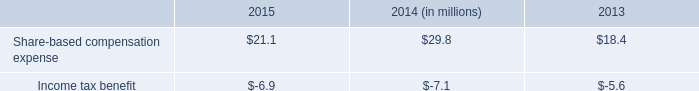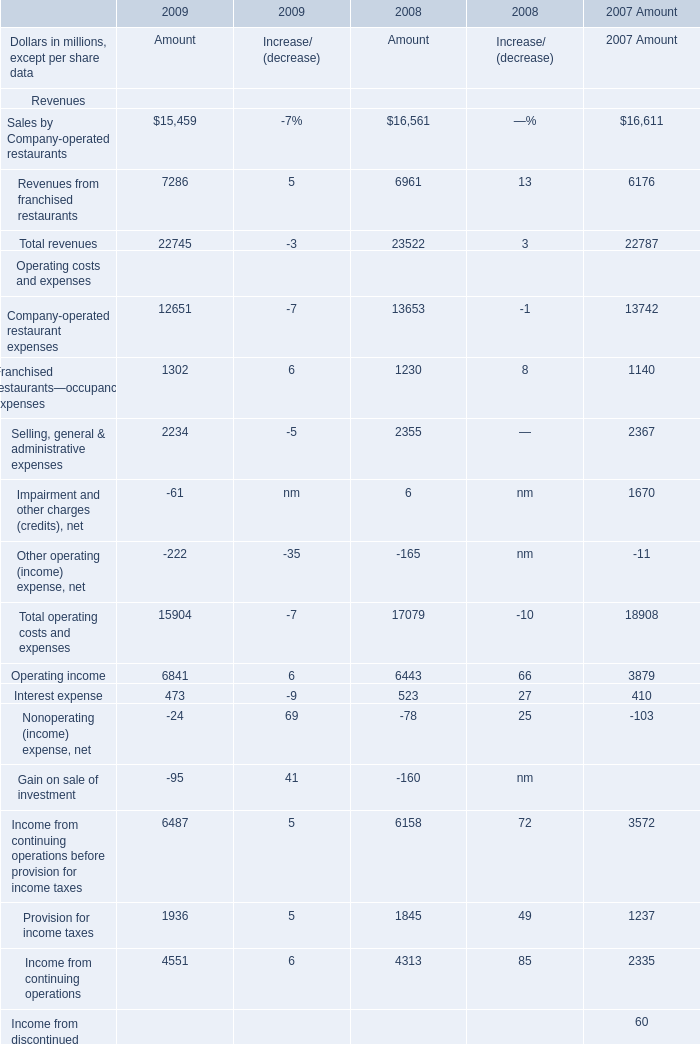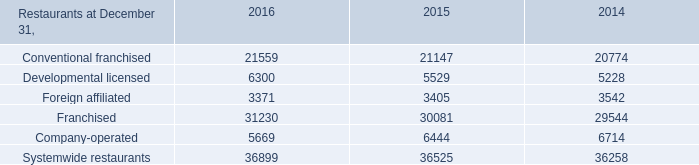what's the total amount of Operating income Operating costs and expenses of 2009 Amount, and Conventional franchised of 2016 ? 
Computations: (6841.0 + 21559.0)
Answer: 28400.0. Which year is Sales by Company-operated restaurants the least? 
Answer: 2009. 